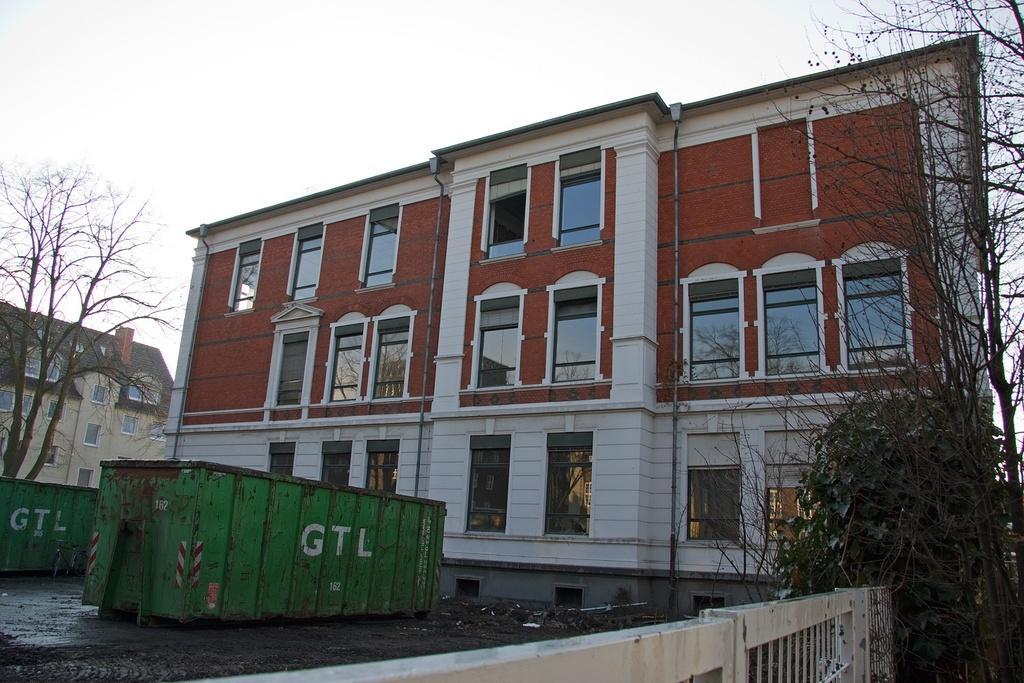Could you give a brief overview of what you see in this image? In this image I can see few buildings, windows, trees and two green containers. The sky is in white color. 